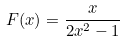Convert formula to latex. <formula><loc_0><loc_0><loc_500><loc_500>F ( x ) = \frac { x } { 2 x ^ { 2 } - 1 }</formula> 